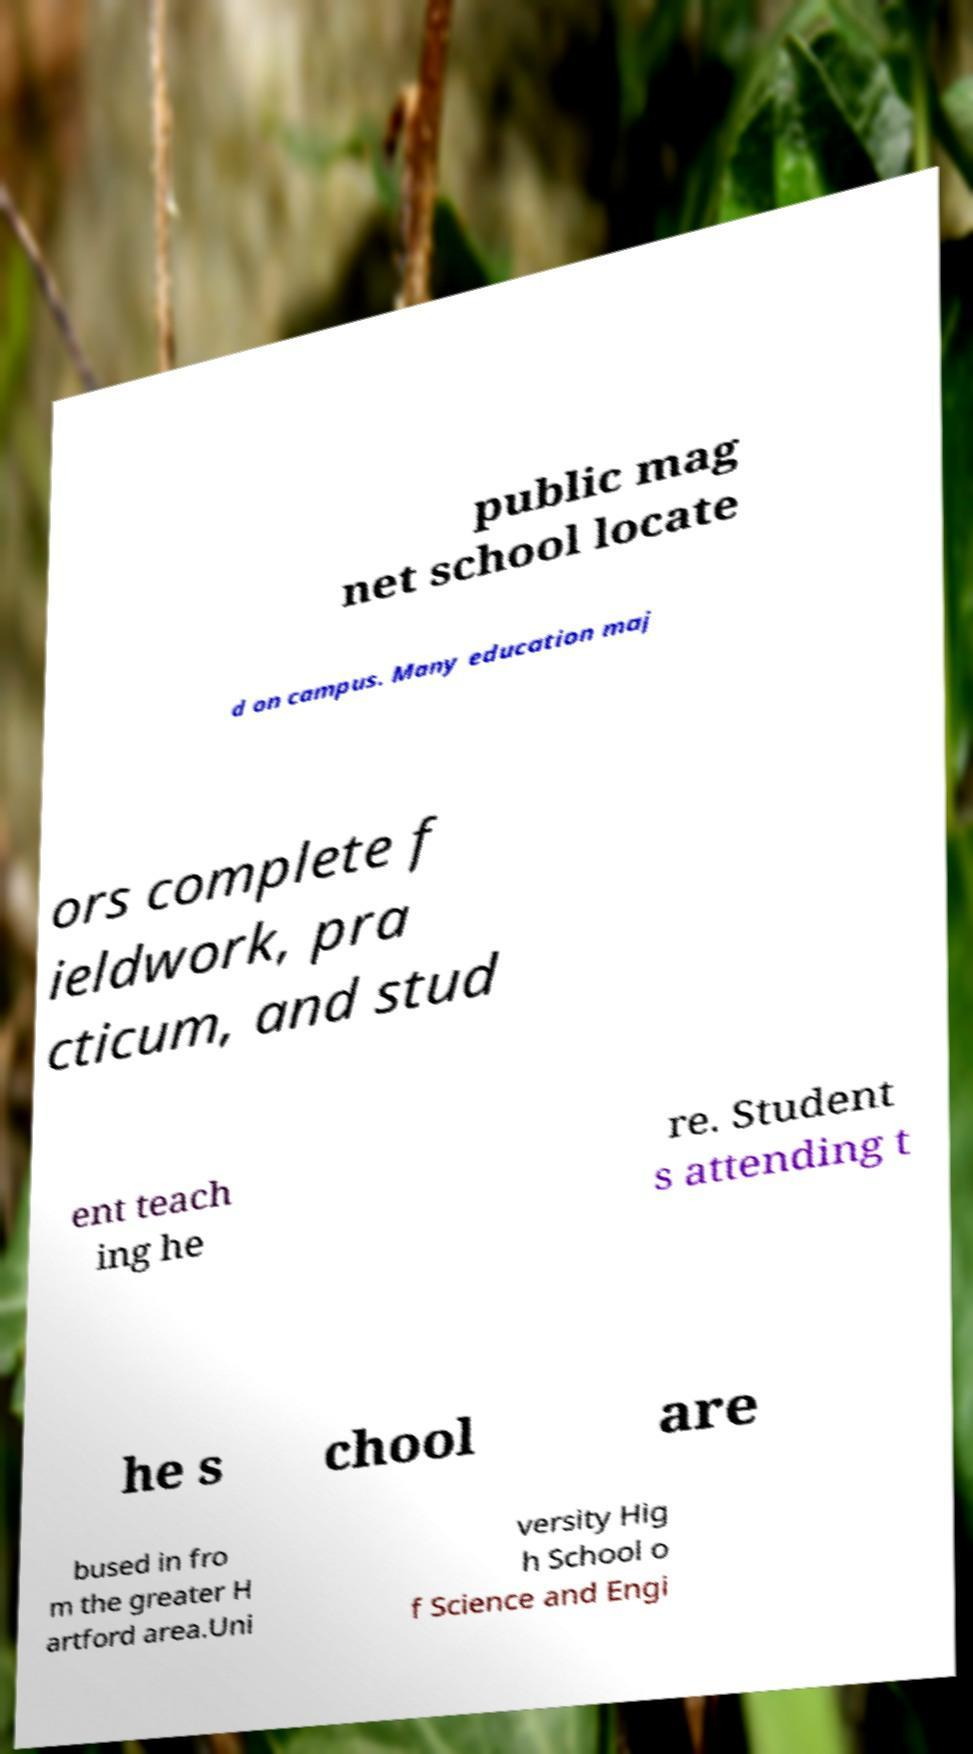For documentation purposes, I need the text within this image transcribed. Could you provide that? public mag net school locate d on campus. Many education maj ors complete f ieldwork, pra cticum, and stud ent teach ing he re. Student s attending t he s chool are bused in fro m the greater H artford area.Uni versity Hig h School o f Science and Engi 